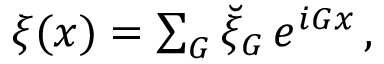<formula> <loc_0><loc_0><loc_500><loc_500>\begin{array} { r } { \xi ( \boldsymbol x ) = \sum _ { G } \breve { \xi } _ { G } \, e ^ { i G x } \, , } \end{array}</formula> 